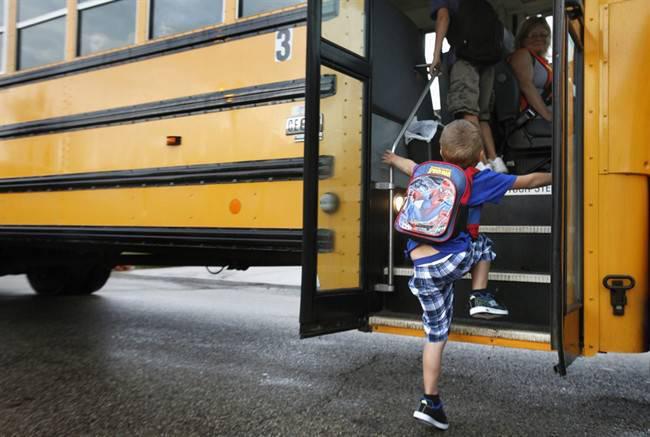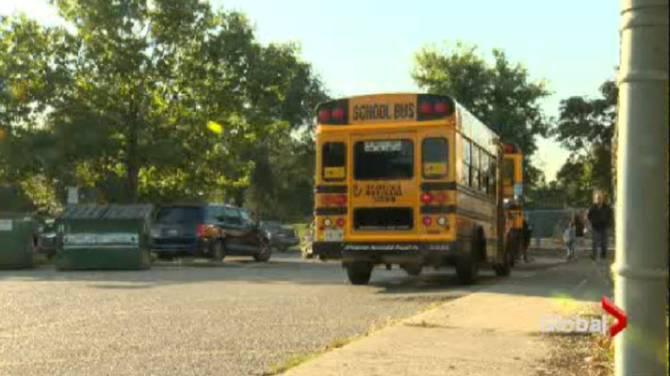The first image is the image on the left, the second image is the image on the right. For the images shown, is this caption "the left and right image contains the same number of buses." true? Answer yes or no. Yes. The first image is the image on the left, the second image is the image on the right. Analyze the images presented: Is the assertion "In the left image, a person is in the open doorway of a bus that faces rightward, with at least one foot on the first step." valid? Answer yes or no. Yes. 